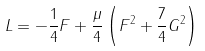<formula> <loc_0><loc_0><loc_500><loc_500>L = - \frac { 1 } { 4 } F + \frac { \mu } { 4 } \left ( F ^ { 2 } + \frac { 7 } { 4 } G ^ { 2 } \right )</formula> 